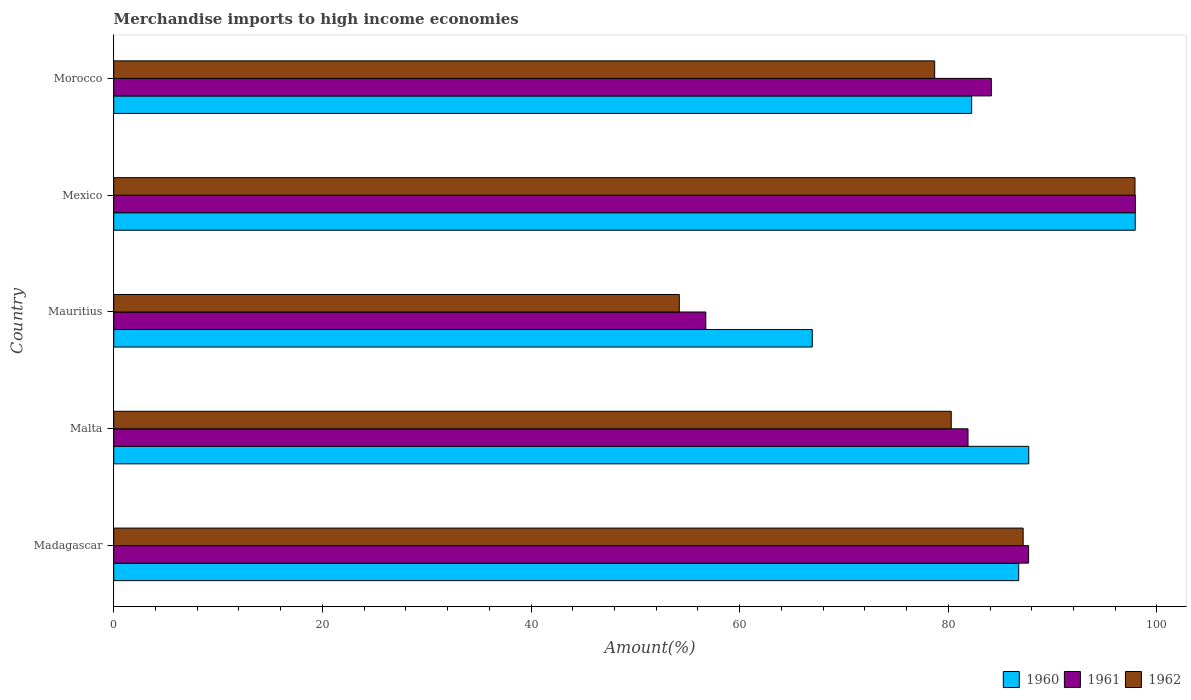How many different coloured bars are there?
Provide a succinct answer. 3. Are the number of bars per tick equal to the number of legend labels?
Provide a succinct answer. Yes. What is the label of the 4th group of bars from the top?
Your answer should be very brief. Malta. What is the percentage of amount earned from merchandise imports in 1960 in Mauritius?
Ensure brevity in your answer.  66.96. Across all countries, what is the maximum percentage of amount earned from merchandise imports in 1961?
Offer a terse response. 97.93. Across all countries, what is the minimum percentage of amount earned from merchandise imports in 1961?
Offer a very short reply. 56.75. In which country was the percentage of amount earned from merchandise imports in 1960 maximum?
Offer a very short reply. Mexico. In which country was the percentage of amount earned from merchandise imports in 1962 minimum?
Keep it short and to the point. Mauritius. What is the total percentage of amount earned from merchandise imports in 1961 in the graph?
Your answer should be compact. 408.39. What is the difference between the percentage of amount earned from merchandise imports in 1961 in Malta and that in Mauritius?
Your answer should be very brief. 25.13. What is the difference between the percentage of amount earned from merchandise imports in 1961 in Mauritius and the percentage of amount earned from merchandise imports in 1960 in Malta?
Make the answer very short. -30.95. What is the average percentage of amount earned from merchandise imports in 1960 per country?
Make the answer very short. 84.31. What is the difference between the percentage of amount earned from merchandise imports in 1962 and percentage of amount earned from merchandise imports in 1960 in Madagascar?
Make the answer very short. 0.43. What is the ratio of the percentage of amount earned from merchandise imports in 1960 in Madagascar to that in Mexico?
Keep it short and to the point. 0.89. Is the difference between the percentage of amount earned from merchandise imports in 1962 in Mauritius and Mexico greater than the difference between the percentage of amount earned from merchandise imports in 1960 in Mauritius and Mexico?
Offer a very short reply. No. What is the difference between the highest and the second highest percentage of amount earned from merchandise imports in 1962?
Provide a short and direct response. 10.72. What is the difference between the highest and the lowest percentage of amount earned from merchandise imports in 1961?
Your answer should be very brief. 41.18. In how many countries, is the percentage of amount earned from merchandise imports in 1961 greater than the average percentage of amount earned from merchandise imports in 1961 taken over all countries?
Your answer should be very brief. 4. What does the 2nd bar from the top in Morocco represents?
Your answer should be very brief. 1961. What does the 1st bar from the bottom in Malta represents?
Provide a succinct answer. 1960. Is it the case that in every country, the sum of the percentage of amount earned from merchandise imports in 1960 and percentage of amount earned from merchandise imports in 1961 is greater than the percentage of amount earned from merchandise imports in 1962?
Provide a short and direct response. Yes. Does the graph contain any zero values?
Keep it short and to the point. No. Does the graph contain grids?
Your answer should be compact. No. Where does the legend appear in the graph?
Keep it short and to the point. Bottom right. How are the legend labels stacked?
Ensure brevity in your answer.  Horizontal. What is the title of the graph?
Provide a short and direct response. Merchandise imports to high income economies. Does "1995" appear as one of the legend labels in the graph?
Your answer should be compact. No. What is the label or title of the X-axis?
Offer a very short reply. Amount(%). What is the Amount(%) in 1960 in Madagascar?
Your answer should be very brief. 86.74. What is the Amount(%) in 1961 in Madagascar?
Ensure brevity in your answer.  87.69. What is the Amount(%) of 1962 in Madagascar?
Make the answer very short. 87.17. What is the Amount(%) in 1960 in Malta?
Your answer should be very brief. 87.71. What is the Amount(%) in 1961 in Malta?
Make the answer very short. 81.89. What is the Amount(%) of 1962 in Malta?
Provide a succinct answer. 80.28. What is the Amount(%) in 1960 in Mauritius?
Ensure brevity in your answer.  66.96. What is the Amount(%) of 1961 in Mauritius?
Offer a terse response. 56.75. What is the Amount(%) of 1962 in Mauritius?
Give a very brief answer. 54.21. What is the Amount(%) of 1960 in Mexico?
Keep it short and to the point. 97.91. What is the Amount(%) in 1961 in Mexico?
Provide a short and direct response. 97.93. What is the Amount(%) in 1962 in Mexico?
Your response must be concise. 97.89. What is the Amount(%) in 1960 in Morocco?
Offer a very short reply. 82.24. What is the Amount(%) of 1961 in Morocco?
Offer a very short reply. 84.12. What is the Amount(%) in 1962 in Morocco?
Your answer should be very brief. 78.69. Across all countries, what is the maximum Amount(%) of 1960?
Ensure brevity in your answer.  97.91. Across all countries, what is the maximum Amount(%) of 1961?
Offer a very short reply. 97.93. Across all countries, what is the maximum Amount(%) of 1962?
Offer a very short reply. 97.89. Across all countries, what is the minimum Amount(%) of 1960?
Your answer should be very brief. 66.96. Across all countries, what is the minimum Amount(%) of 1961?
Your answer should be compact. 56.75. Across all countries, what is the minimum Amount(%) of 1962?
Keep it short and to the point. 54.21. What is the total Amount(%) of 1960 in the graph?
Your answer should be very brief. 421.56. What is the total Amount(%) of 1961 in the graph?
Provide a succinct answer. 408.39. What is the total Amount(%) of 1962 in the graph?
Provide a short and direct response. 398.24. What is the difference between the Amount(%) of 1960 in Madagascar and that in Malta?
Offer a very short reply. -0.96. What is the difference between the Amount(%) in 1961 in Madagascar and that in Malta?
Your response must be concise. 5.81. What is the difference between the Amount(%) in 1962 in Madagascar and that in Malta?
Your response must be concise. 6.89. What is the difference between the Amount(%) of 1960 in Madagascar and that in Mauritius?
Ensure brevity in your answer.  19.79. What is the difference between the Amount(%) of 1961 in Madagascar and that in Mauritius?
Offer a very short reply. 30.94. What is the difference between the Amount(%) of 1962 in Madagascar and that in Mauritius?
Provide a succinct answer. 32.96. What is the difference between the Amount(%) in 1960 in Madagascar and that in Mexico?
Your response must be concise. -11.17. What is the difference between the Amount(%) of 1961 in Madagascar and that in Mexico?
Your answer should be compact. -10.24. What is the difference between the Amount(%) in 1962 in Madagascar and that in Mexico?
Give a very brief answer. -10.72. What is the difference between the Amount(%) in 1960 in Madagascar and that in Morocco?
Ensure brevity in your answer.  4.51. What is the difference between the Amount(%) of 1961 in Madagascar and that in Morocco?
Provide a succinct answer. 3.57. What is the difference between the Amount(%) in 1962 in Madagascar and that in Morocco?
Provide a succinct answer. 8.48. What is the difference between the Amount(%) of 1960 in Malta and that in Mauritius?
Your answer should be compact. 20.75. What is the difference between the Amount(%) in 1961 in Malta and that in Mauritius?
Your answer should be very brief. 25.13. What is the difference between the Amount(%) in 1962 in Malta and that in Mauritius?
Give a very brief answer. 26.07. What is the difference between the Amount(%) of 1960 in Malta and that in Mexico?
Make the answer very short. -10.2. What is the difference between the Amount(%) of 1961 in Malta and that in Mexico?
Keep it short and to the point. -16.05. What is the difference between the Amount(%) in 1962 in Malta and that in Mexico?
Offer a very short reply. -17.61. What is the difference between the Amount(%) of 1960 in Malta and that in Morocco?
Keep it short and to the point. 5.47. What is the difference between the Amount(%) in 1961 in Malta and that in Morocco?
Your answer should be compact. -2.24. What is the difference between the Amount(%) of 1962 in Malta and that in Morocco?
Your response must be concise. 1.59. What is the difference between the Amount(%) of 1960 in Mauritius and that in Mexico?
Give a very brief answer. -30.95. What is the difference between the Amount(%) of 1961 in Mauritius and that in Mexico?
Keep it short and to the point. -41.18. What is the difference between the Amount(%) in 1962 in Mauritius and that in Mexico?
Provide a succinct answer. -43.68. What is the difference between the Amount(%) of 1960 in Mauritius and that in Morocco?
Make the answer very short. -15.28. What is the difference between the Amount(%) of 1961 in Mauritius and that in Morocco?
Your answer should be very brief. -27.37. What is the difference between the Amount(%) in 1962 in Mauritius and that in Morocco?
Your answer should be very brief. -24.48. What is the difference between the Amount(%) of 1960 in Mexico and that in Morocco?
Your response must be concise. 15.68. What is the difference between the Amount(%) of 1961 in Mexico and that in Morocco?
Give a very brief answer. 13.81. What is the difference between the Amount(%) of 1962 in Mexico and that in Morocco?
Provide a succinct answer. 19.2. What is the difference between the Amount(%) in 1960 in Madagascar and the Amount(%) in 1961 in Malta?
Your answer should be very brief. 4.86. What is the difference between the Amount(%) in 1960 in Madagascar and the Amount(%) in 1962 in Malta?
Your response must be concise. 6.47. What is the difference between the Amount(%) in 1961 in Madagascar and the Amount(%) in 1962 in Malta?
Your answer should be very brief. 7.42. What is the difference between the Amount(%) in 1960 in Madagascar and the Amount(%) in 1961 in Mauritius?
Your answer should be very brief. 29.99. What is the difference between the Amount(%) in 1960 in Madagascar and the Amount(%) in 1962 in Mauritius?
Keep it short and to the point. 32.53. What is the difference between the Amount(%) of 1961 in Madagascar and the Amount(%) of 1962 in Mauritius?
Give a very brief answer. 33.48. What is the difference between the Amount(%) in 1960 in Madagascar and the Amount(%) in 1961 in Mexico?
Keep it short and to the point. -11.19. What is the difference between the Amount(%) of 1960 in Madagascar and the Amount(%) of 1962 in Mexico?
Provide a succinct answer. -11.15. What is the difference between the Amount(%) of 1961 in Madagascar and the Amount(%) of 1962 in Mexico?
Your answer should be very brief. -10.2. What is the difference between the Amount(%) in 1960 in Madagascar and the Amount(%) in 1961 in Morocco?
Provide a succinct answer. 2.62. What is the difference between the Amount(%) of 1960 in Madagascar and the Amount(%) of 1962 in Morocco?
Offer a very short reply. 8.05. What is the difference between the Amount(%) in 1961 in Madagascar and the Amount(%) in 1962 in Morocco?
Give a very brief answer. 9. What is the difference between the Amount(%) of 1960 in Malta and the Amount(%) of 1961 in Mauritius?
Ensure brevity in your answer.  30.95. What is the difference between the Amount(%) in 1960 in Malta and the Amount(%) in 1962 in Mauritius?
Give a very brief answer. 33.5. What is the difference between the Amount(%) of 1961 in Malta and the Amount(%) of 1962 in Mauritius?
Offer a very short reply. 27.68. What is the difference between the Amount(%) in 1960 in Malta and the Amount(%) in 1961 in Mexico?
Provide a succinct answer. -10.22. What is the difference between the Amount(%) of 1960 in Malta and the Amount(%) of 1962 in Mexico?
Offer a terse response. -10.19. What is the difference between the Amount(%) of 1961 in Malta and the Amount(%) of 1962 in Mexico?
Offer a terse response. -16.01. What is the difference between the Amount(%) in 1960 in Malta and the Amount(%) in 1961 in Morocco?
Your answer should be very brief. 3.58. What is the difference between the Amount(%) of 1960 in Malta and the Amount(%) of 1962 in Morocco?
Make the answer very short. 9.02. What is the difference between the Amount(%) in 1961 in Malta and the Amount(%) in 1962 in Morocco?
Give a very brief answer. 3.2. What is the difference between the Amount(%) of 1960 in Mauritius and the Amount(%) of 1961 in Mexico?
Keep it short and to the point. -30.97. What is the difference between the Amount(%) of 1960 in Mauritius and the Amount(%) of 1962 in Mexico?
Keep it short and to the point. -30.93. What is the difference between the Amount(%) of 1961 in Mauritius and the Amount(%) of 1962 in Mexico?
Provide a short and direct response. -41.14. What is the difference between the Amount(%) of 1960 in Mauritius and the Amount(%) of 1961 in Morocco?
Your answer should be very brief. -17.16. What is the difference between the Amount(%) of 1960 in Mauritius and the Amount(%) of 1962 in Morocco?
Make the answer very short. -11.73. What is the difference between the Amount(%) of 1961 in Mauritius and the Amount(%) of 1962 in Morocco?
Provide a short and direct response. -21.94. What is the difference between the Amount(%) in 1960 in Mexico and the Amount(%) in 1961 in Morocco?
Make the answer very short. 13.79. What is the difference between the Amount(%) in 1960 in Mexico and the Amount(%) in 1962 in Morocco?
Give a very brief answer. 19.22. What is the difference between the Amount(%) of 1961 in Mexico and the Amount(%) of 1962 in Morocco?
Provide a short and direct response. 19.24. What is the average Amount(%) of 1960 per country?
Keep it short and to the point. 84.31. What is the average Amount(%) in 1961 per country?
Keep it short and to the point. 81.68. What is the average Amount(%) of 1962 per country?
Your answer should be compact. 79.65. What is the difference between the Amount(%) of 1960 and Amount(%) of 1961 in Madagascar?
Keep it short and to the point. -0.95. What is the difference between the Amount(%) in 1960 and Amount(%) in 1962 in Madagascar?
Make the answer very short. -0.43. What is the difference between the Amount(%) in 1961 and Amount(%) in 1962 in Madagascar?
Offer a terse response. 0.52. What is the difference between the Amount(%) in 1960 and Amount(%) in 1961 in Malta?
Offer a terse response. 5.82. What is the difference between the Amount(%) of 1960 and Amount(%) of 1962 in Malta?
Your answer should be very brief. 7.43. What is the difference between the Amount(%) of 1961 and Amount(%) of 1962 in Malta?
Provide a short and direct response. 1.61. What is the difference between the Amount(%) of 1960 and Amount(%) of 1961 in Mauritius?
Your response must be concise. 10.21. What is the difference between the Amount(%) in 1960 and Amount(%) in 1962 in Mauritius?
Your answer should be compact. 12.75. What is the difference between the Amount(%) in 1961 and Amount(%) in 1962 in Mauritius?
Offer a very short reply. 2.54. What is the difference between the Amount(%) in 1960 and Amount(%) in 1961 in Mexico?
Your answer should be very brief. -0.02. What is the difference between the Amount(%) in 1960 and Amount(%) in 1962 in Mexico?
Give a very brief answer. 0.02. What is the difference between the Amount(%) of 1961 and Amount(%) of 1962 in Mexico?
Your response must be concise. 0.04. What is the difference between the Amount(%) in 1960 and Amount(%) in 1961 in Morocco?
Ensure brevity in your answer.  -1.89. What is the difference between the Amount(%) in 1960 and Amount(%) in 1962 in Morocco?
Keep it short and to the point. 3.54. What is the difference between the Amount(%) in 1961 and Amount(%) in 1962 in Morocco?
Offer a very short reply. 5.43. What is the ratio of the Amount(%) in 1961 in Madagascar to that in Malta?
Your answer should be very brief. 1.07. What is the ratio of the Amount(%) of 1962 in Madagascar to that in Malta?
Provide a short and direct response. 1.09. What is the ratio of the Amount(%) of 1960 in Madagascar to that in Mauritius?
Offer a terse response. 1.3. What is the ratio of the Amount(%) of 1961 in Madagascar to that in Mauritius?
Offer a terse response. 1.55. What is the ratio of the Amount(%) in 1962 in Madagascar to that in Mauritius?
Ensure brevity in your answer.  1.61. What is the ratio of the Amount(%) of 1960 in Madagascar to that in Mexico?
Your response must be concise. 0.89. What is the ratio of the Amount(%) of 1961 in Madagascar to that in Mexico?
Make the answer very short. 0.9. What is the ratio of the Amount(%) of 1962 in Madagascar to that in Mexico?
Provide a succinct answer. 0.89. What is the ratio of the Amount(%) in 1960 in Madagascar to that in Morocco?
Keep it short and to the point. 1.05. What is the ratio of the Amount(%) in 1961 in Madagascar to that in Morocco?
Offer a very short reply. 1.04. What is the ratio of the Amount(%) in 1962 in Madagascar to that in Morocco?
Keep it short and to the point. 1.11. What is the ratio of the Amount(%) in 1960 in Malta to that in Mauritius?
Provide a succinct answer. 1.31. What is the ratio of the Amount(%) of 1961 in Malta to that in Mauritius?
Provide a succinct answer. 1.44. What is the ratio of the Amount(%) of 1962 in Malta to that in Mauritius?
Your answer should be compact. 1.48. What is the ratio of the Amount(%) in 1960 in Malta to that in Mexico?
Give a very brief answer. 0.9. What is the ratio of the Amount(%) in 1961 in Malta to that in Mexico?
Offer a terse response. 0.84. What is the ratio of the Amount(%) in 1962 in Malta to that in Mexico?
Keep it short and to the point. 0.82. What is the ratio of the Amount(%) of 1960 in Malta to that in Morocco?
Ensure brevity in your answer.  1.07. What is the ratio of the Amount(%) in 1961 in Malta to that in Morocco?
Your answer should be very brief. 0.97. What is the ratio of the Amount(%) in 1962 in Malta to that in Morocco?
Your answer should be very brief. 1.02. What is the ratio of the Amount(%) in 1960 in Mauritius to that in Mexico?
Ensure brevity in your answer.  0.68. What is the ratio of the Amount(%) of 1961 in Mauritius to that in Mexico?
Keep it short and to the point. 0.58. What is the ratio of the Amount(%) in 1962 in Mauritius to that in Mexico?
Your response must be concise. 0.55. What is the ratio of the Amount(%) in 1960 in Mauritius to that in Morocco?
Offer a terse response. 0.81. What is the ratio of the Amount(%) of 1961 in Mauritius to that in Morocco?
Provide a succinct answer. 0.67. What is the ratio of the Amount(%) in 1962 in Mauritius to that in Morocco?
Offer a terse response. 0.69. What is the ratio of the Amount(%) of 1960 in Mexico to that in Morocco?
Ensure brevity in your answer.  1.19. What is the ratio of the Amount(%) in 1961 in Mexico to that in Morocco?
Offer a terse response. 1.16. What is the ratio of the Amount(%) of 1962 in Mexico to that in Morocco?
Offer a terse response. 1.24. What is the difference between the highest and the second highest Amount(%) of 1960?
Provide a short and direct response. 10.2. What is the difference between the highest and the second highest Amount(%) of 1961?
Provide a succinct answer. 10.24. What is the difference between the highest and the second highest Amount(%) in 1962?
Make the answer very short. 10.72. What is the difference between the highest and the lowest Amount(%) of 1960?
Offer a very short reply. 30.95. What is the difference between the highest and the lowest Amount(%) of 1961?
Keep it short and to the point. 41.18. What is the difference between the highest and the lowest Amount(%) in 1962?
Your answer should be very brief. 43.68. 